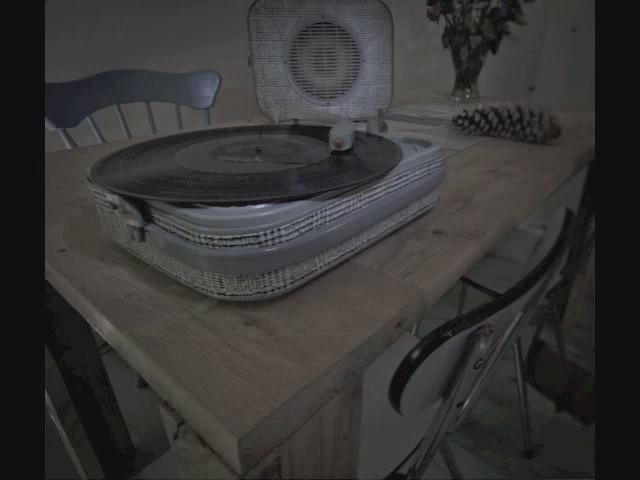What is this machine is being used to make?
Answer briefly. Music. Is this modern instrument?
Short answer required. No. What is this?
Be succinct. Record player. What room is this?
Keep it brief. Dining room. What room would you find this in at a house?
Keep it brief. Dining room. How many cups are in the photo?
Short answer required. 0. Do the chairs match?
Quick response, please. No. Is there a spray bottle in the photo?
Give a very brief answer. No. Do any of the devices have a place to plug something into them?
Keep it brief. No. Can the fan cool the whole room?
Give a very brief answer. No. Is this cake real or a decorative example?
Answer briefly. No cake. What type of furniture is this?
Write a very short answer. Table. Is there a toilet?
Write a very short answer. No. How many chairs are there?
Quick response, please. 2. What is this appliance?
Answer briefly. Record player. What style record player is this?
Quick response, please. Old. Is there a trash can in this picture?
Be succinct. No. Is there a toilet in the picture?
Answer briefly. No. What kind of room is this?
Give a very brief answer. Dining room. Is this a magnifying glass?
Write a very short answer. No. Is the record being played?
Answer briefly. Yes. Is this room a bathroom?
Keep it brief. No. 